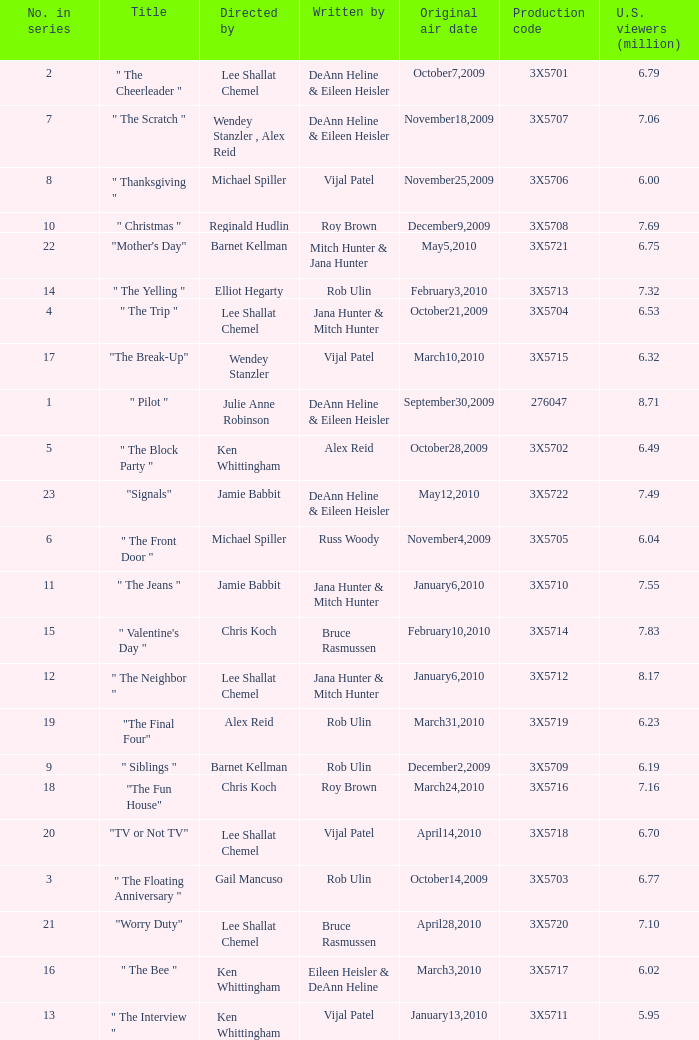How many directors got 6.79 million U.S. viewers from their episodes? 1.0. 